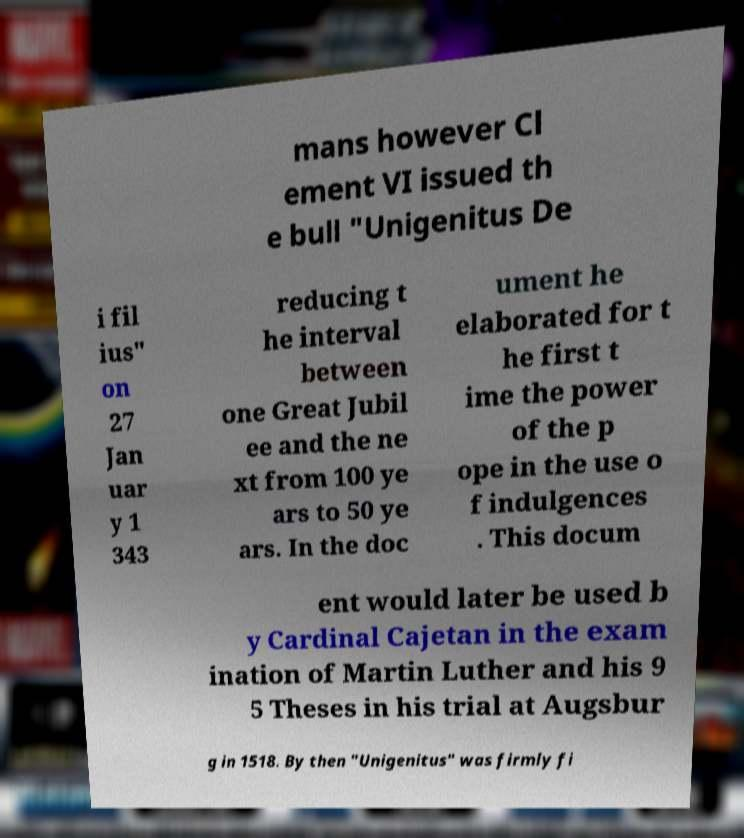Can you read and provide the text displayed in the image?This photo seems to have some interesting text. Can you extract and type it out for me? mans however Cl ement VI issued th e bull "Unigenitus De i fil ius" on 27 Jan uar y 1 343 reducing t he interval between one Great Jubil ee and the ne xt from 100 ye ars to 50 ye ars. In the doc ument he elaborated for t he first t ime the power of the p ope in the use o f indulgences . This docum ent would later be used b y Cardinal Cajetan in the exam ination of Martin Luther and his 9 5 Theses in his trial at Augsbur g in 1518. By then "Unigenitus" was firmly fi 